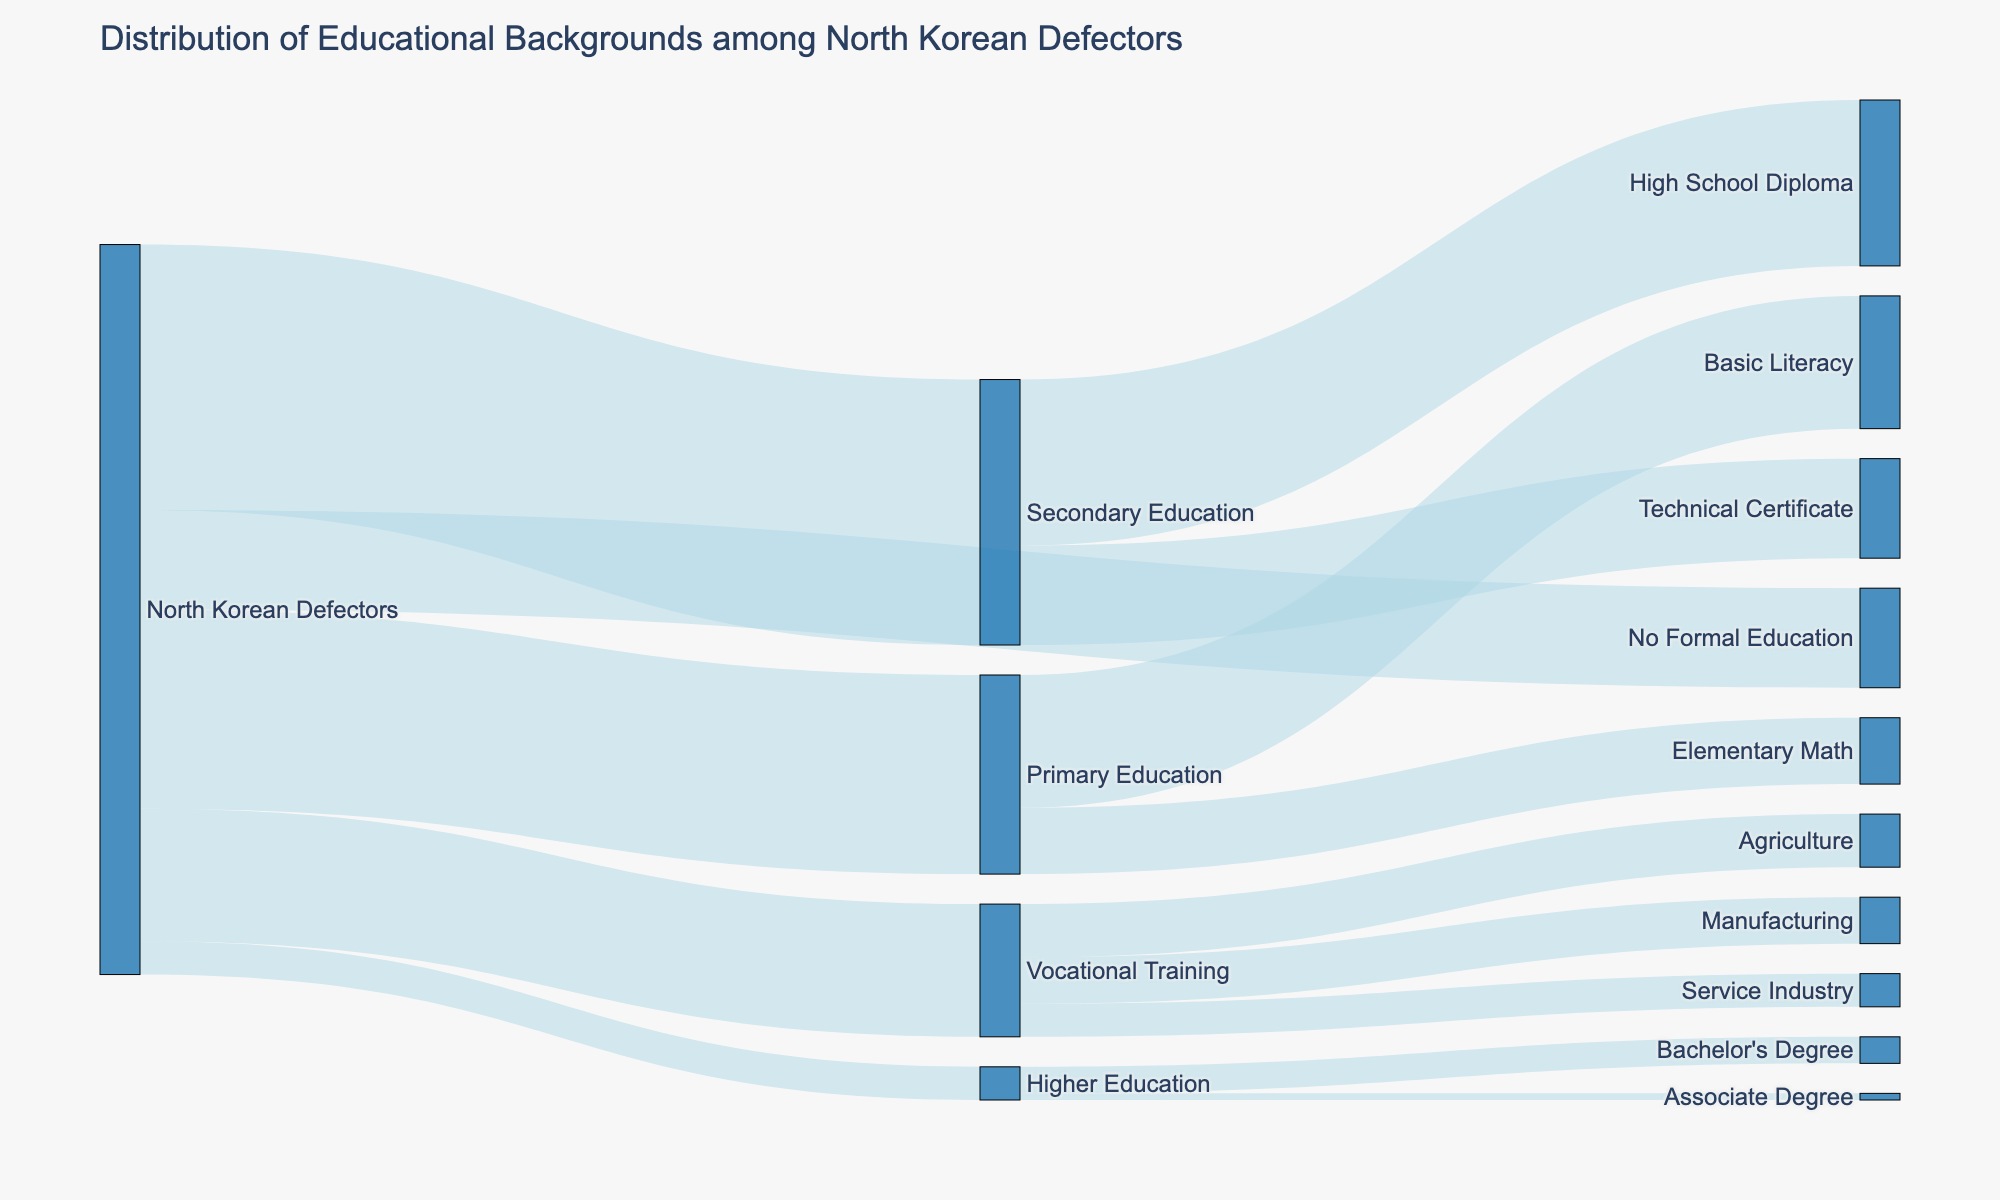What is the title of the diagram? The title is typically located at the top of the diagram. By reading the text in that area, you can determine the title.
Answer: Distribution of Educational Backgrounds among North Korean Defectors How many North Korean Defectors have a Primary Education? By looking at the width of the flow from 'North Korean Defectors' to 'Primary Education', the number will be displayed.
Answer: 300 What percentage of the North Korean Defectors have received no formal education? Calculate the percentage using the number of defectors with no formal education (150) divided by the total number of defectors (150 + 300 + 400 + 200 + 50), then multiply by 100. The total is 1100, so (150/1100) * 100 = 13.64%.
Answer: 13.64% Which educational level received the highest number of defectors? By comparing the widths of the flows from 'North Korean Defectors' to each educational level, the largest flow indicates the highest number.
Answer: Secondary Education How many defectors opted for Vocational Training in Manufacturing? Follow the flow from 'Vocational Training' to 'Manufacturing' to find the number indicated beside it.
Answer: 70 What is the combined number of defectors with a High School Diploma and those with a Technical Certificate? Add the values for High School Diploma (250) and Technical Certificate (150). 250 + 150 = 400.
Answer: 400 Which field within Vocational Training has the fewest defectors? Compare the flows going from 'Vocational Training' to Agriculture, Manufacturing, and Service Industry to determine which is the smallest.
Answer: Service Industry How many defectors pursued higher education? Look at the width of the flow from 'North Korean Defectors' to 'Higher Education' to find the number indicated beside it.
Answer: 50 What is the difference between the number of defectors with Primary Education and those with Secondary Education? Subtract the number who have Primary Education (300) from those with Secondary Education (400). 400 - 300 = 100.
Answer: 100 What percentage of those with Primary Education achieved Basic Literacy? Calculate the percentage using the number of those with Basic Literacy (200) divided by the total number of Primary Education defectors (300), then multiply by 100. (200/300) * 100 = 66.67%.
Answer: 66.67% 